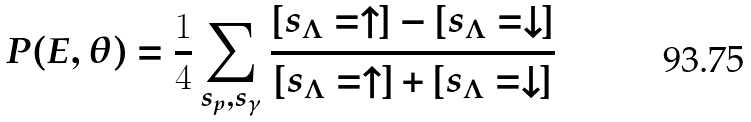<formula> <loc_0><loc_0><loc_500><loc_500>P ( E , \theta ) = \frac { 1 } { 4 } \sum _ { s _ { p } , s _ { \gamma } } \frac { [ s _ { \Lambda } = \uparrow ] - [ s _ { \Lambda } = \downarrow ] } { [ s _ { \Lambda } = \uparrow ] + [ s _ { \Lambda } = \downarrow ] }</formula> 